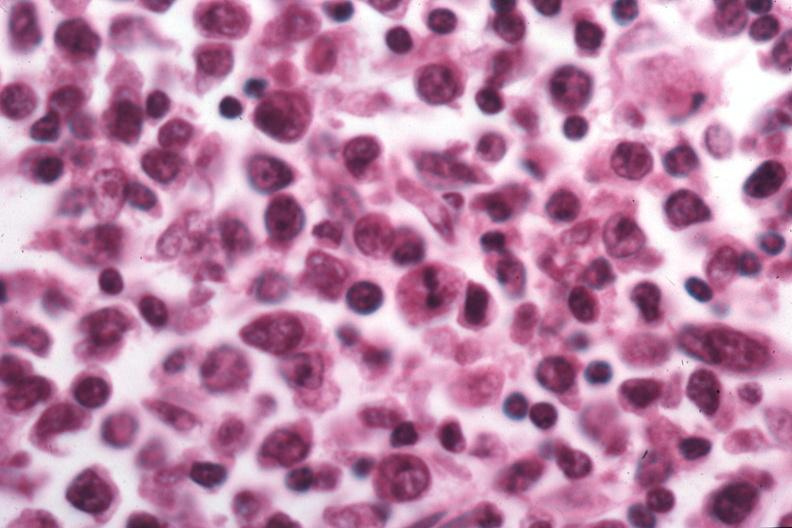does foot show that pleocellular large cell would be best classification?
Answer the question using a single word or phrase. No 